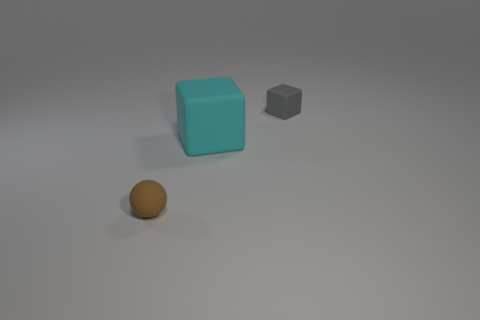Is there any other thing that has the same size as the cyan rubber object?
Offer a terse response. No. Does the gray thing have the same shape as the big cyan object that is to the left of the small gray matte object?
Provide a short and direct response. Yes. There is a tiny object that is right of the rubber cube that is in front of the gray block; is there a gray rubber object that is on the right side of it?
Ensure brevity in your answer.  No. What is the size of the brown object?
Your response must be concise. Small. What number of other things are the same color as the small ball?
Your response must be concise. 0. There is a small matte thing on the right side of the small brown ball; is it the same shape as the cyan matte thing?
Your response must be concise. Yes. What is the color of the large object that is the same shape as the tiny gray thing?
Provide a succinct answer. Cyan. There is another thing that is the same shape as the cyan rubber thing; what size is it?
Your answer should be compact. Small. Is the color of the small thing that is in front of the gray thing the same as the big object?
Your answer should be compact. No. Are there any big cyan rubber blocks to the right of the small cube?
Your answer should be compact. No. 